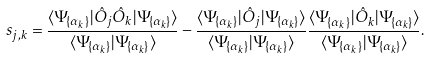<formula> <loc_0><loc_0><loc_500><loc_500>s _ { j , k } = \frac { \langle \Psi _ { \{ \alpha _ { k } \} } | { \hat { O } } _ { j } { \hat { O } } _ { k } | \Psi _ { \{ \alpha _ { k } \} } \rangle } { \langle \Psi _ { \{ \alpha _ { k } \} } | \Psi _ { \{ \alpha _ { k } \} } \rangle } - \frac { \langle \Psi _ { \{ \alpha _ { k } \} } | { \hat { O } } _ { j } | \Psi _ { \{ \alpha _ { k } \} } \rangle } { \langle \Psi _ { \{ \alpha _ { k } \} } | \Psi _ { \{ \alpha _ { k } \} } \rangle } \frac { \langle \Psi _ { \{ \alpha _ { k } \} } | { \hat { O } } _ { k } | \Psi _ { \{ \alpha _ { k } \} } \rangle } { \langle \Psi _ { \{ \alpha _ { k } \} } | \Psi _ { \{ \alpha _ { k } \} } \rangle } .</formula> 